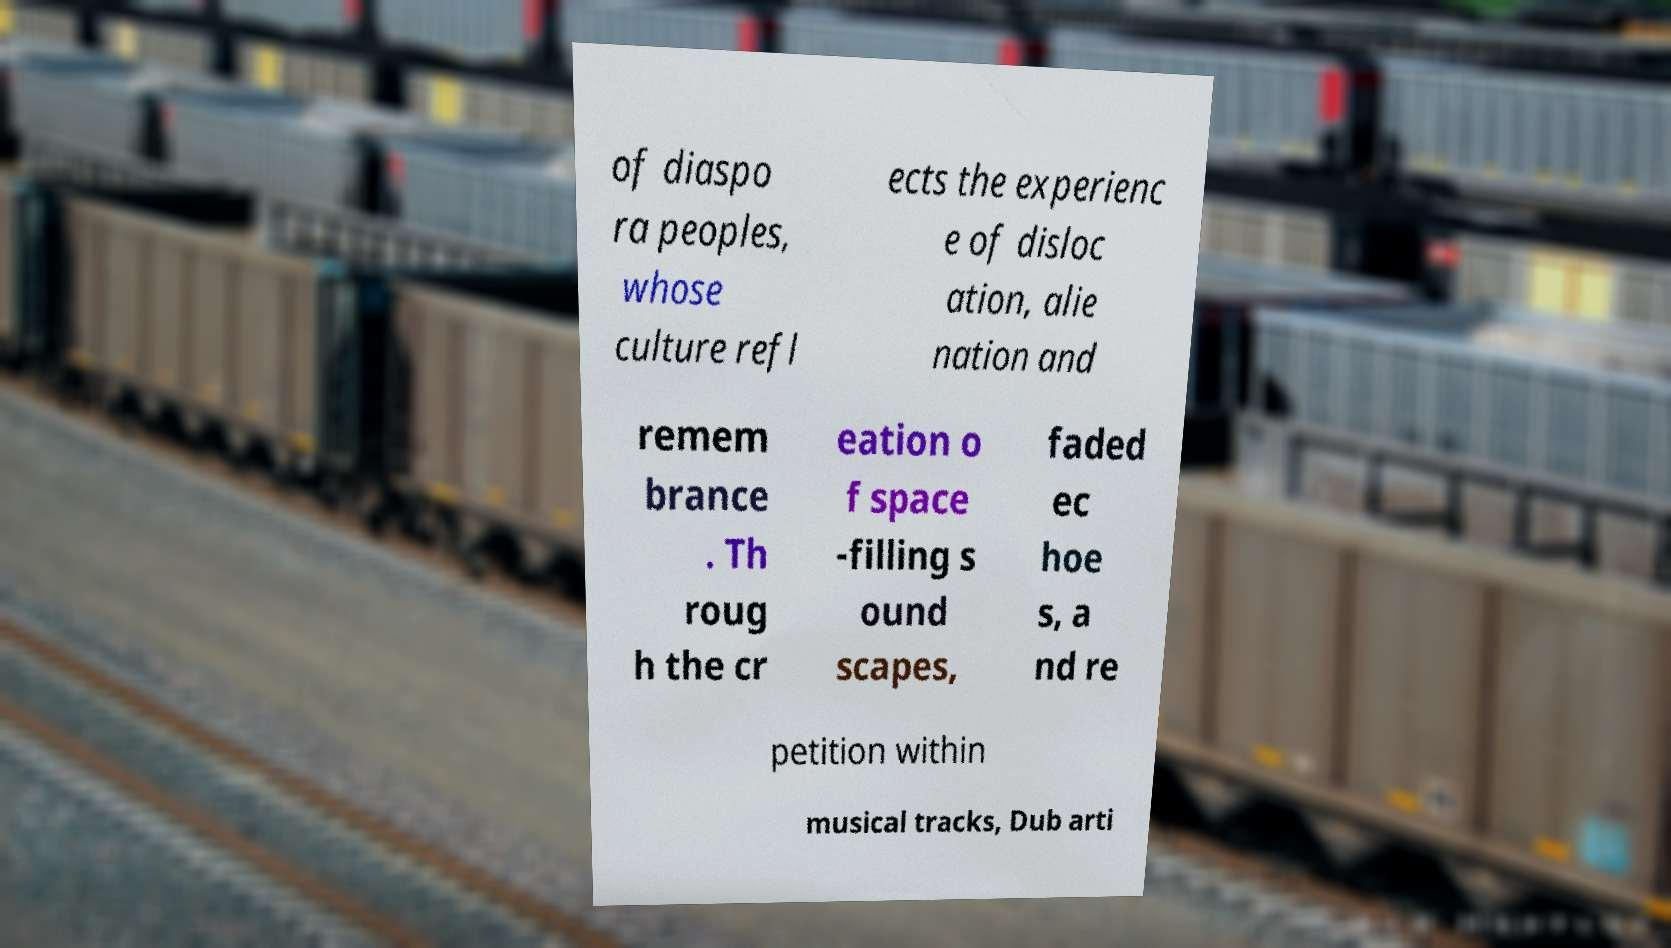Could you assist in decoding the text presented in this image and type it out clearly? of diaspo ra peoples, whose culture refl ects the experienc e of disloc ation, alie nation and remem brance . Th roug h the cr eation o f space -filling s ound scapes, faded ec hoe s, a nd re petition within musical tracks, Dub arti 